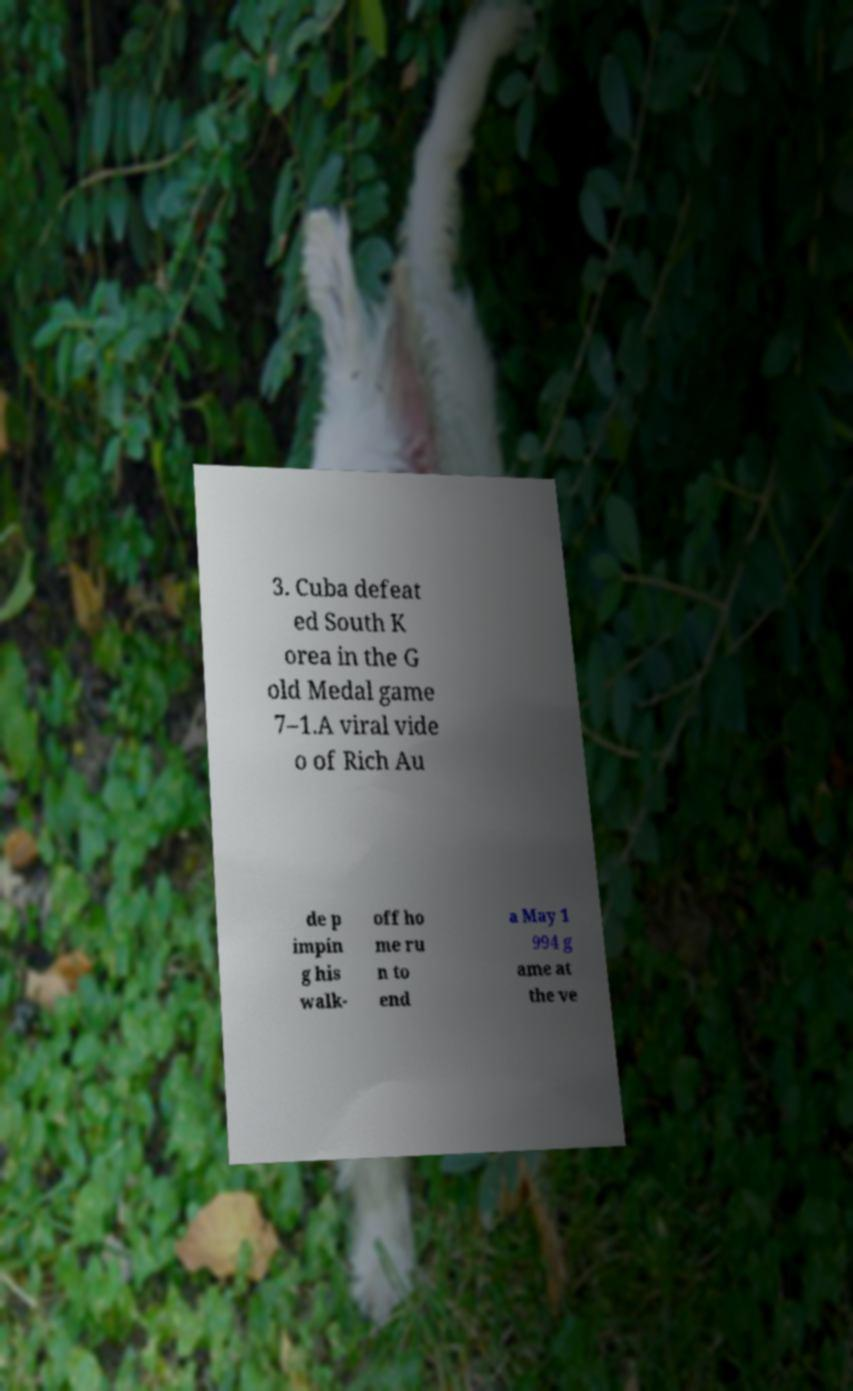Can you accurately transcribe the text from the provided image for me? 3. Cuba defeat ed South K orea in the G old Medal game 7–1.A viral vide o of Rich Au de p impin g his walk- off ho me ru n to end a May 1 994 g ame at the ve 